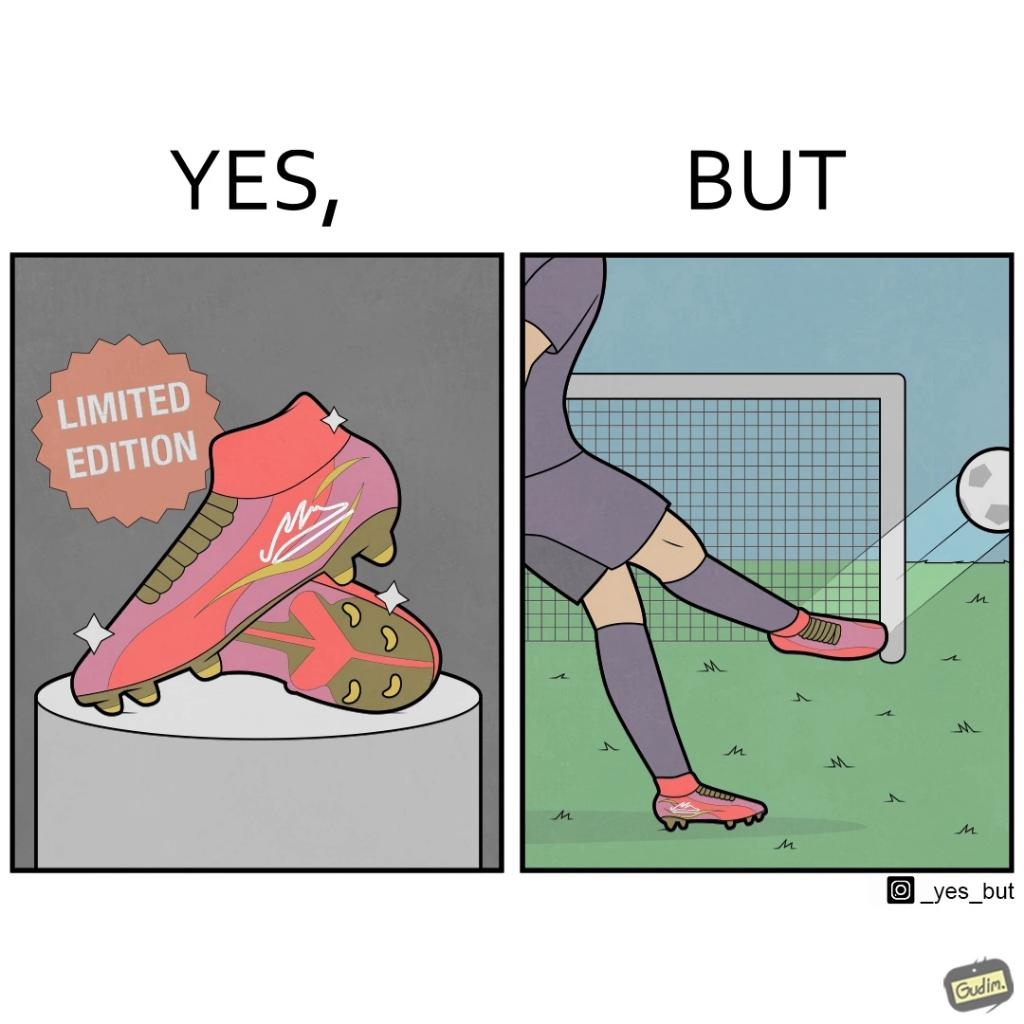Is this image satirical or non-satirical? Yes, this image is satirical. 